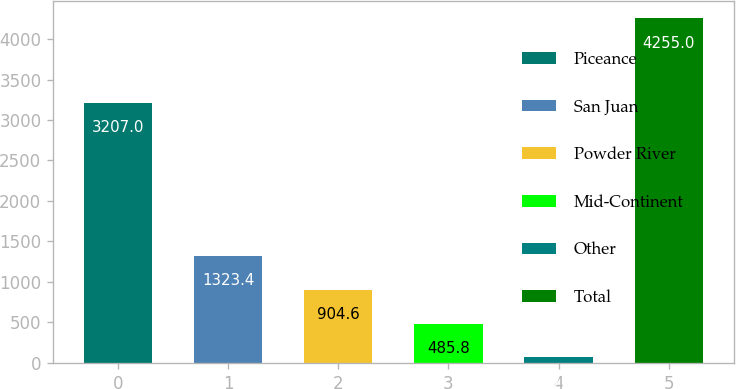Convert chart. <chart><loc_0><loc_0><loc_500><loc_500><bar_chart><fcel>Piceance<fcel>San Juan<fcel>Powder River<fcel>Mid-Continent<fcel>Other<fcel>Total<nl><fcel>3207<fcel>1323.4<fcel>904.6<fcel>485.8<fcel>67<fcel>4255<nl></chart> 